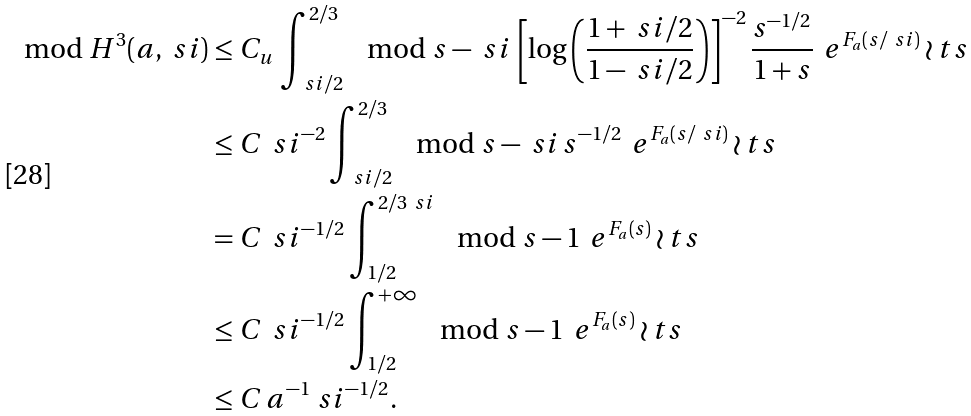<formula> <loc_0><loc_0><loc_500><loc_500>\mod { H ^ { 3 } ( a , \ s i ) } & \leq C _ { u } \, \int ^ { 2 / 3 } _ { \ s i / 2 } \mod { s - \ s i } \, \left [ \log \left ( \frac { 1 + \ s i / 2 } { 1 - \ s i / 2 } \right ) \right ] ^ { - 2 } \frac { s ^ { - 1 / 2 } } { 1 + s } \, \ e ^ { F _ { a } ( s / \ s i ) } \wr t s \\ & \leq C \, \ s i ^ { - 2 } \int ^ { 2 / 3 } _ { \ s i / 2 } \mod { s - \ s i } \, s ^ { - 1 / 2 } \, \ e ^ { F _ { a } ( s / \ s i ) } \wr t s \\ & = C \, \ s i ^ { - 1 / 2 } \int ^ { 2 / 3 \ s i } _ { 1 / 2 } \mod { s - 1 } \, \ e ^ { F _ { a } ( s ) } \wr t s \\ & \leq C \, \ s i ^ { - 1 / 2 } \int ^ { + \infty } _ { 1 / 2 } \mod { s - 1 } \, \ e ^ { F _ { a } ( s ) } \wr t s \\ & \leq C \, a ^ { - 1 } \ s i ^ { - 1 / 2 } .</formula> 